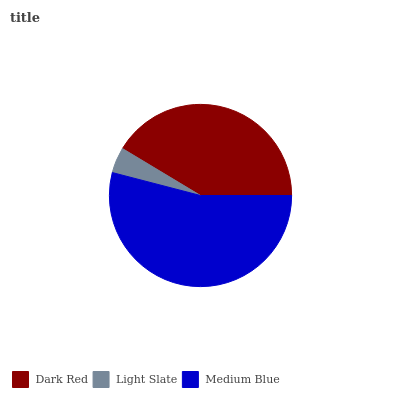Is Light Slate the minimum?
Answer yes or no. Yes. Is Medium Blue the maximum?
Answer yes or no. Yes. Is Medium Blue the minimum?
Answer yes or no. No. Is Light Slate the maximum?
Answer yes or no. No. Is Medium Blue greater than Light Slate?
Answer yes or no. Yes. Is Light Slate less than Medium Blue?
Answer yes or no. Yes. Is Light Slate greater than Medium Blue?
Answer yes or no. No. Is Medium Blue less than Light Slate?
Answer yes or no. No. Is Dark Red the high median?
Answer yes or no. Yes. Is Dark Red the low median?
Answer yes or no. Yes. Is Medium Blue the high median?
Answer yes or no. No. Is Medium Blue the low median?
Answer yes or no. No. 